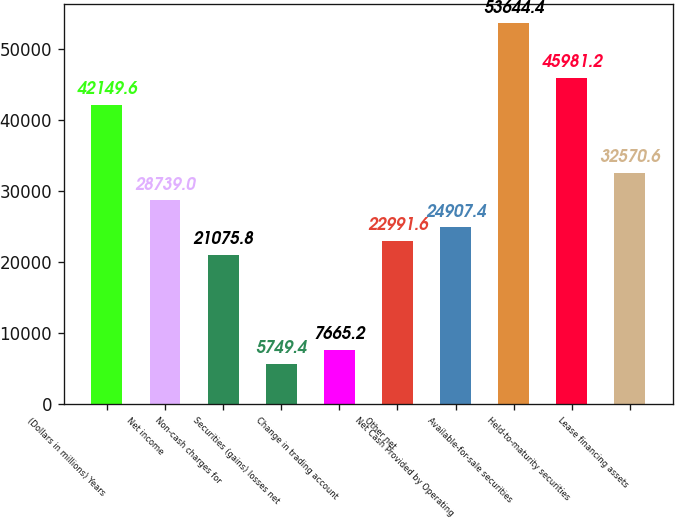Convert chart. <chart><loc_0><loc_0><loc_500><loc_500><bar_chart><fcel>(Dollars in millions) Years<fcel>Net income<fcel>Non-cash charges for<fcel>Securities (gains) losses net<fcel>Change in trading account<fcel>Other net<fcel>Net Cash Provided by Operating<fcel>Available-for-sale securities<fcel>Held-to-maturity securities<fcel>Lease financing assets<nl><fcel>42149.6<fcel>28739<fcel>21075.8<fcel>5749.4<fcel>7665.2<fcel>22991.6<fcel>24907.4<fcel>53644.4<fcel>45981.2<fcel>32570.6<nl></chart> 